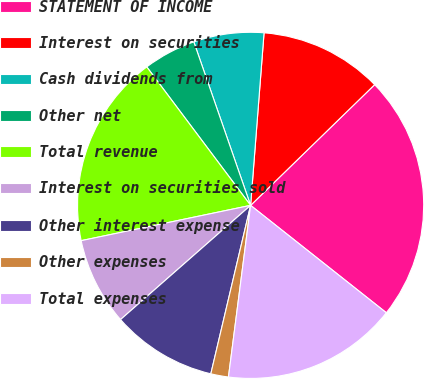Convert chart. <chart><loc_0><loc_0><loc_500><loc_500><pie_chart><fcel>STATEMENT OF INCOME<fcel>Interest on securities<fcel>Cash dividends from<fcel>Other net<fcel>Total revenue<fcel>Interest on securities sold<fcel>Other interest expense<fcel>Other expenses<fcel>Total expenses<nl><fcel>22.94%<fcel>11.48%<fcel>6.56%<fcel>4.92%<fcel>18.03%<fcel>8.2%<fcel>9.84%<fcel>1.65%<fcel>16.39%<nl></chart> 